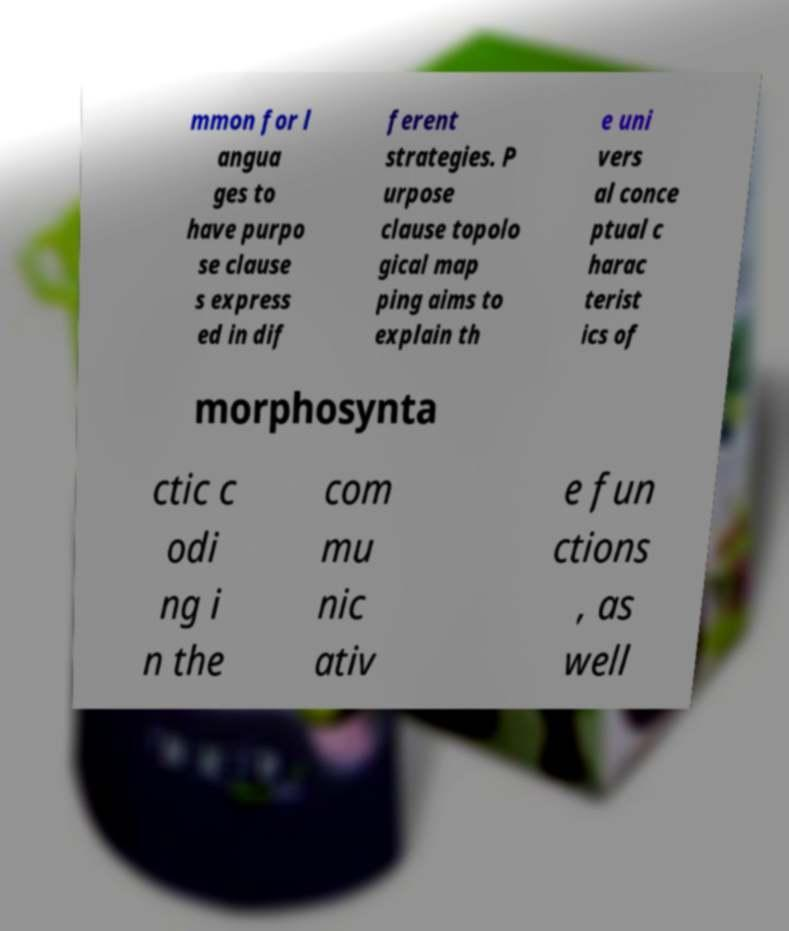What messages or text are displayed in this image? I need them in a readable, typed format. mmon for l angua ges to have purpo se clause s express ed in dif ferent strategies. P urpose clause topolo gical map ping aims to explain th e uni vers al conce ptual c harac terist ics of morphosynta ctic c odi ng i n the com mu nic ativ e fun ctions , as well 